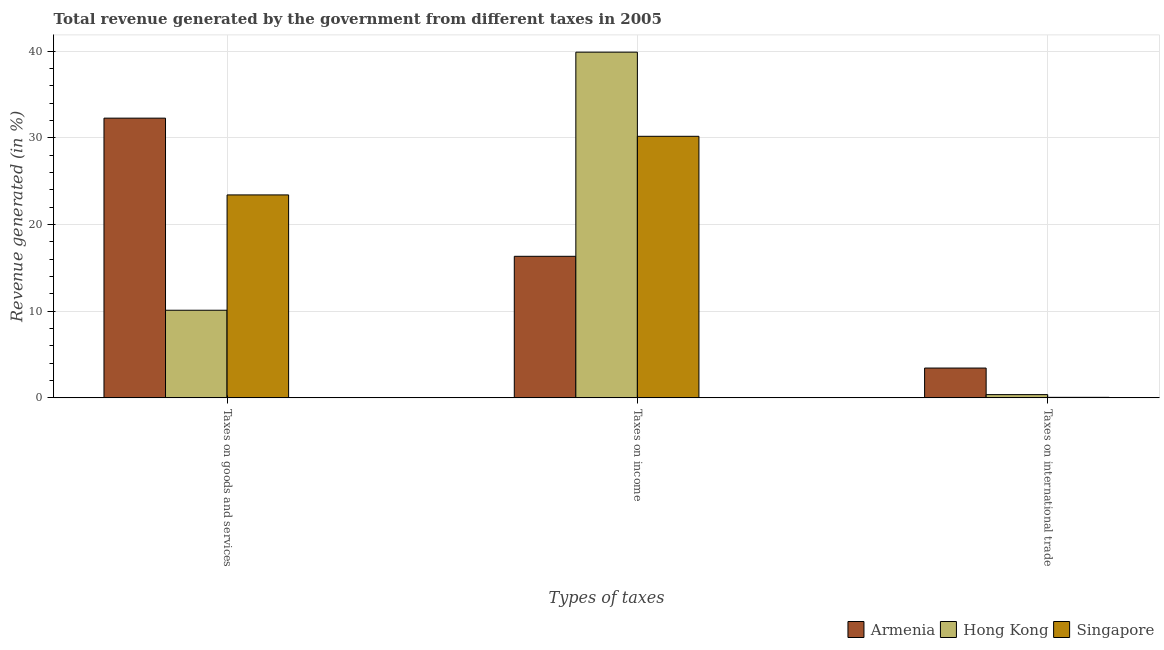How many bars are there on the 3rd tick from the left?
Your answer should be very brief. 3. How many bars are there on the 2nd tick from the right?
Your answer should be very brief. 3. What is the label of the 1st group of bars from the left?
Offer a very short reply. Taxes on goods and services. What is the percentage of revenue generated by tax on international trade in Armenia?
Keep it short and to the point. 3.44. Across all countries, what is the maximum percentage of revenue generated by tax on international trade?
Your answer should be compact. 3.44. Across all countries, what is the minimum percentage of revenue generated by taxes on goods and services?
Your answer should be very brief. 10.11. In which country was the percentage of revenue generated by taxes on income maximum?
Give a very brief answer. Hong Kong. In which country was the percentage of revenue generated by taxes on income minimum?
Your response must be concise. Armenia. What is the total percentage of revenue generated by taxes on goods and services in the graph?
Ensure brevity in your answer.  65.77. What is the difference between the percentage of revenue generated by tax on international trade in Hong Kong and that in Singapore?
Your answer should be compact. 0.31. What is the difference between the percentage of revenue generated by tax on international trade in Singapore and the percentage of revenue generated by taxes on goods and services in Armenia?
Offer a very short reply. -32.2. What is the average percentage of revenue generated by taxes on goods and services per country?
Offer a terse response. 21.92. What is the difference between the percentage of revenue generated by tax on international trade and percentage of revenue generated by taxes on income in Armenia?
Your answer should be compact. -12.89. What is the ratio of the percentage of revenue generated by taxes on goods and services in Hong Kong to that in Singapore?
Keep it short and to the point. 0.43. Is the percentage of revenue generated by taxes on income in Armenia less than that in Singapore?
Keep it short and to the point. Yes. Is the difference between the percentage of revenue generated by tax on international trade in Singapore and Hong Kong greater than the difference between the percentage of revenue generated by taxes on income in Singapore and Hong Kong?
Offer a terse response. Yes. What is the difference between the highest and the second highest percentage of revenue generated by taxes on goods and services?
Your answer should be very brief. 8.85. What is the difference between the highest and the lowest percentage of revenue generated by tax on international trade?
Provide a succinct answer. 3.38. In how many countries, is the percentage of revenue generated by taxes on goods and services greater than the average percentage of revenue generated by taxes on goods and services taken over all countries?
Offer a terse response. 2. Is the sum of the percentage of revenue generated by taxes on goods and services in Singapore and Armenia greater than the maximum percentage of revenue generated by taxes on income across all countries?
Give a very brief answer. Yes. What does the 1st bar from the left in Taxes on income represents?
Give a very brief answer. Armenia. What does the 2nd bar from the right in Taxes on goods and services represents?
Your answer should be compact. Hong Kong. Is it the case that in every country, the sum of the percentage of revenue generated by taxes on goods and services and percentage of revenue generated by taxes on income is greater than the percentage of revenue generated by tax on international trade?
Give a very brief answer. Yes. How many bars are there?
Your answer should be compact. 9. Are all the bars in the graph horizontal?
Provide a succinct answer. No. How many countries are there in the graph?
Your answer should be very brief. 3. What is the difference between two consecutive major ticks on the Y-axis?
Offer a very short reply. 10. Are the values on the major ticks of Y-axis written in scientific E-notation?
Provide a succinct answer. No. Does the graph contain any zero values?
Your answer should be compact. No. Where does the legend appear in the graph?
Offer a very short reply. Bottom right. How many legend labels are there?
Make the answer very short. 3. How are the legend labels stacked?
Your answer should be very brief. Horizontal. What is the title of the graph?
Offer a very short reply. Total revenue generated by the government from different taxes in 2005. Does "Bhutan" appear as one of the legend labels in the graph?
Offer a terse response. No. What is the label or title of the X-axis?
Keep it short and to the point. Types of taxes. What is the label or title of the Y-axis?
Provide a succinct answer. Revenue generated (in %). What is the Revenue generated (in %) in Armenia in Taxes on goods and services?
Offer a terse response. 32.26. What is the Revenue generated (in %) of Hong Kong in Taxes on goods and services?
Give a very brief answer. 10.11. What is the Revenue generated (in %) in Singapore in Taxes on goods and services?
Your answer should be compact. 23.41. What is the Revenue generated (in %) in Armenia in Taxes on income?
Your answer should be very brief. 16.33. What is the Revenue generated (in %) in Hong Kong in Taxes on income?
Your answer should be compact. 39.87. What is the Revenue generated (in %) of Singapore in Taxes on income?
Offer a very short reply. 30.17. What is the Revenue generated (in %) in Armenia in Taxes on international trade?
Your response must be concise. 3.44. What is the Revenue generated (in %) in Hong Kong in Taxes on international trade?
Offer a very short reply. 0.38. What is the Revenue generated (in %) in Singapore in Taxes on international trade?
Keep it short and to the point. 0.06. Across all Types of taxes, what is the maximum Revenue generated (in %) in Armenia?
Ensure brevity in your answer.  32.26. Across all Types of taxes, what is the maximum Revenue generated (in %) in Hong Kong?
Provide a short and direct response. 39.87. Across all Types of taxes, what is the maximum Revenue generated (in %) in Singapore?
Offer a terse response. 30.17. Across all Types of taxes, what is the minimum Revenue generated (in %) of Armenia?
Ensure brevity in your answer.  3.44. Across all Types of taxes, what is the minimum Revenue generated (in %) in Hong Kong?
Offer a terse response. 0.38. Across all Types of taxes, what is the minimum Revenue generated (in %) in Singapore?
Offer a very short reply. 0.06. What is the total Revenue generated (in %) of Armenia in the graph?
Make the answer very short. 52.03. What is the total Revenue generated (in %) in Hong Kong in the graph?
Ensure brevity in your answer.  50.35. What is the total Revenue generated (in %) of Singapore in the graph?
Provide a succinct answer. 53.64. What is the difference between the Revenue generated (in %) in Armenia in Taxes on goods and services and that in Taxes on income?
Your answer should be compact. 15.93. What is the difference between the Revenue generated (in %) in Hong Kong in Taxes on goods and services and that in Taxes on income?
Offer a very short reply. -29.76. What is the difference between the Revenue generated (in %) of Singapore in Taxes on goods and services and that in Taxes on income?
Your response must be concise. -6.76. What is the difference between the Revenue generated (in %) in Armenia in Taxes on goods and services and that in Taxes on international trade?
Your answer should be very brief. 28.82. What is the difference between the Revenue generated (in %) of Hong Kong in Taxes on goods and services and that in Taxes on international trade?
Offer a terse response. 9.73. What is the difference between the Revenue generated (in %) of Singapore in Taxes on goods and services and that in Taxes on international trade?
Your answer should be very brief. 23.35. What is the difference between the Revenue generated (in %) in Armenia in Taxes on income and that in Taxes on international trade?
Provide a short and direct response. 12.89. What is the difference between the Revenue generated (in %) in Hong Kong in Taxes on income and that in Taxes on international trade?
Offer a very short reply. 39.5. What is the difference between the Revenue generated (in %) of Singapore in Taxes on income and that in Taxes on international trade?
Your answer should be compact. 30.1. What is the difference between the Revenue generated (in %) of Armenia in Taxes on goods and services and the Revenue generated (in %) of Hong Kong in Taxes on income?
Your response must be concise. -7.61. What is the difference between the Revenue generated (in %) of Armenia in Taxes on goods and services and the Revenue generated (in %) of Singapore in Taxes on income?
Give a very brief answer. 2.09. What is the difference between the Revenue generated (in %) in Hong Kong in Taxes on goods and services and the Revenue generated (in %) in Singapore in Taxes on income?
Make the answer very short. -20.06. What is the difference between the Revenue generated (in %) in Armenia in Taxes on goods and services and the Revenue generated (in %) in Hong Kong in Taxes on international trade?
Keep it short and to the point. 31.89. What is the difference between the Revenue generated (in %) of Armenia in Taxes on goods and services and the Revenue generated (in %) of Singapore in Taxes on international trade?
Your response must be concise. 32.2. What is the difference between the Revenue generated (in %) of Hong Kong in Taxes on goods and services and the Revenue generated (in %) of Singapore in Taxes on international trade?
Offer a terse response. 10.04. What is the difference between the Revenue generated (in %) in Armenia in Taxes on income and the Revenue generated (in %) in Hong Kong in Taxes on international trade?
Keep it short and to the point. 15.95. What is the difference between the Revenue generated (in %) in Armenia in Taxes on income and the Revenue generated (in %) in Singapore in Taxes on international trade?
Give a very brief answer. 16.27. What is the difference between the Revenue generated (in %) in Hong Kong in Taxes on income and the Revenue generated (in %) in Singapore in Taxes on international trade?
Your response must be concise. 39.81. What is the average Revenue generated (in %) in Armenia per Types of taxes?
Keep it short and to the point. 17.34. What is the average Revenue generated (in %) of Hong Kong per Types of taxes?
Provide a short and direct response. 16.78. What is the average Revenue generated (in %) in Singapore per Types of taxes?
Ensure brevity in your answer.  17.88. What is the difference between the Revenue generated (in %) in Armenia and Revenue generated (in %) in Hong Kong in Taxes on goods and services?
Give a very brief answer. 22.15. What is the difference between the Revenue generated (in %) of Armenia and Revenue generated (in %) of Singapore in Taxes on goods and services?
Provide a short and direct response. 8.85. What is the difference between the Revenue generated (in %) in Hong Kong and Revenue generated (in %) in Singapore in Taxes on goods and services?
Ensure brevity in your answer.  -13.3. What is the difference between the Revenue generated (in %) in Armenia and Revenue generated (in %) in Hong Kong in Taxes on income?
Offer a very short reply. -23.54. What is the difference between the Revenue generated (in %) of Armenia and Revenue generated (in %) of Singapore in Taxes on income?
Offer a very short reply. -13.84. What is the difference between the Revenue generated (in %) of Hong Kong and Revenue generated (in %) of Singapore in Taxes on income?
Offer a very short reply. 9.7. What is the difference between the Revenue generated (in %) of Armenia and Revenue generated (in %) of Hong Kong in Taxes on international trade?
Offer a very short reply. 3.06. What is the difference between the Revenue generated (in %) of Armenia and Revenue generated (in %) of Singapore in Taxes on international trade?
Your answer should be very brief. 3.38. What is the difference between the Revenue generated (in %) of Hong Kong and Revenue generated (in %) of Singapore in Taxes on international trade?
Provide a short and direct response. 0.31. What is the ratio of the Revenue generated (in %) of Armenia in Taxes on goods and services to that in Taxes on income?
Keep it short and to the point. 1.98. What is the ratio of the Revenue generated (in %) in Hong Kong in Taxes on goods and services to that in Taxes on income?
Offer a very short reply. 0.25. What is the ratio of the Revenue generated (in %) in Singapore in Taxes on goods and services to that in Taxes on income?
Your answer should be very brief. 0.78. What is the ratio of the Revenue generated (in %) in Armenia in Taxes on goods and services to that in Taxes on international trade?
Your answer should be compact. 9.38. What is the ratio of the Revenue generated (in %) in Hong Kong in Taxes on goods and services to that in Taxes on international trade?
Give a very brief answer. 26.9. What is the ratio of the Revenue generated (in %) of Singapore in Taxes on goods and services to that in Taxes on international trade?
Offer a very short reply. 377.08. What is the ratio of the Revenue generated (in %) of Armenia in Taxes on income to that in Taxes on international trade?
Offer a terse response. 4.75. What is the ratio of the Revenue generated (in %) of Hong Kong in Taxes on income to that in Taxes on international trade?
Your response must be concise. 106.13. What is the ratio of the Revenue generated (in %) in Singapore in Taxes on income to that in Taxes on international trade?
Provide a short and direct response. 485.96. What is the difference between the highest and the second highest Revenue generated (in %) of Armenia?
Provide a succinct answer. 15.93. What is the difference between the highest and the second highest Revenue generated (in %) in Hong Kong?
Your answer should be very brief. 29.76. What is the difference between the highest and the second highest Revenue generated (in %) of Singapore?
Make the answer very short. 6.76. What is the difference between the highest and the lowest Revenue generated (in %) in Armenia?
Keep it short and to the point. 28.82. What is the difference between the highest and the lowest Revenue generated (in %) of Hong Kong?
Provide a short and direct response. 39.5. What is the difference between the highest and the lowest Revenue generated (in %) in Singapore?
Provide a short and direct response. 30.1. 